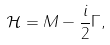<formula> <loc_0><loc_0><loc_500><loc_500>\mathcal { H } = M - \frac { i } { 2 } \Gamma ,</formula> 